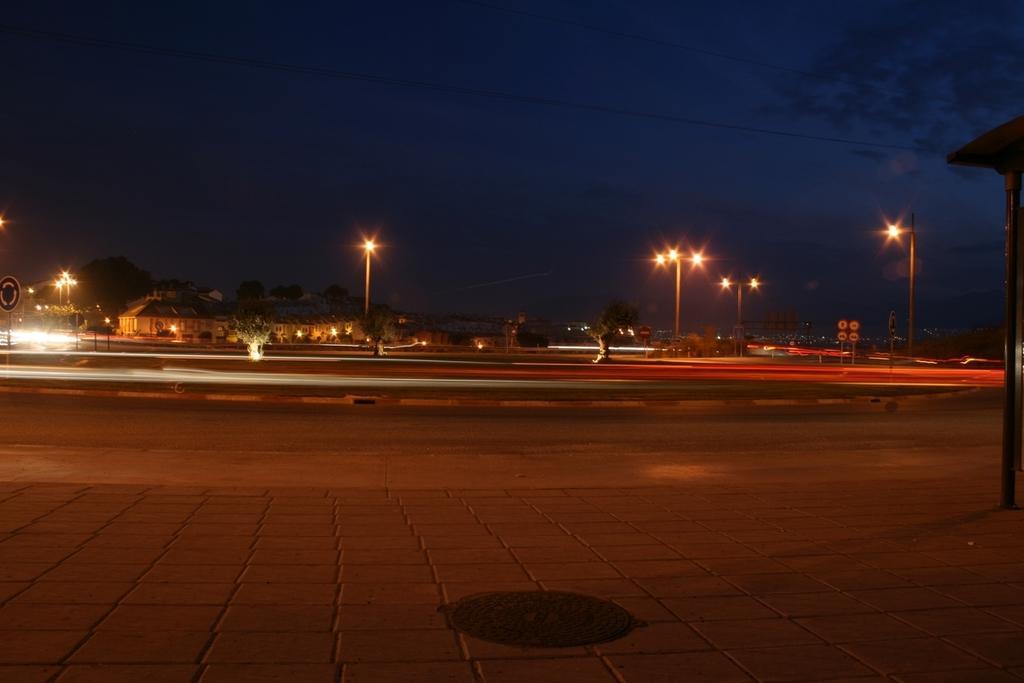How would you summarize this image in a sentence or two? In this image I can see a road in the front. In the background I can see number of trees, number of poles, number of street lights, clouds and the sky. I can also see a sign board on the left side of this image. 